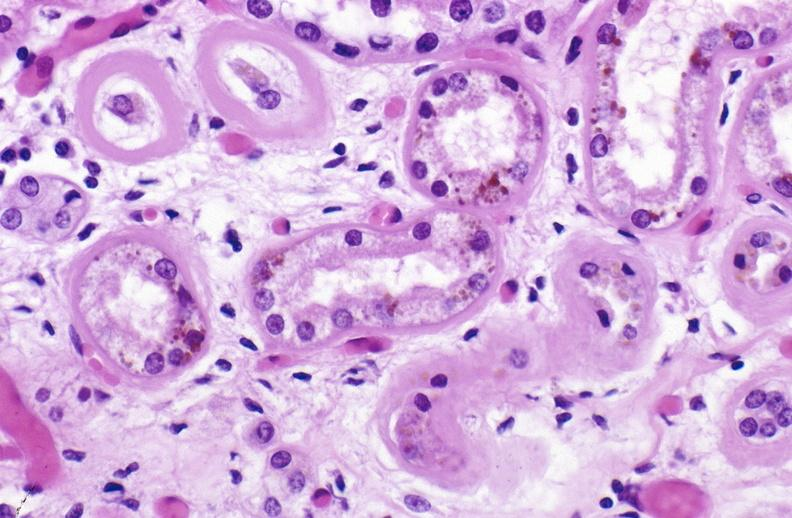s urinary present?
Answer the question using a single word or phrase. Yes 